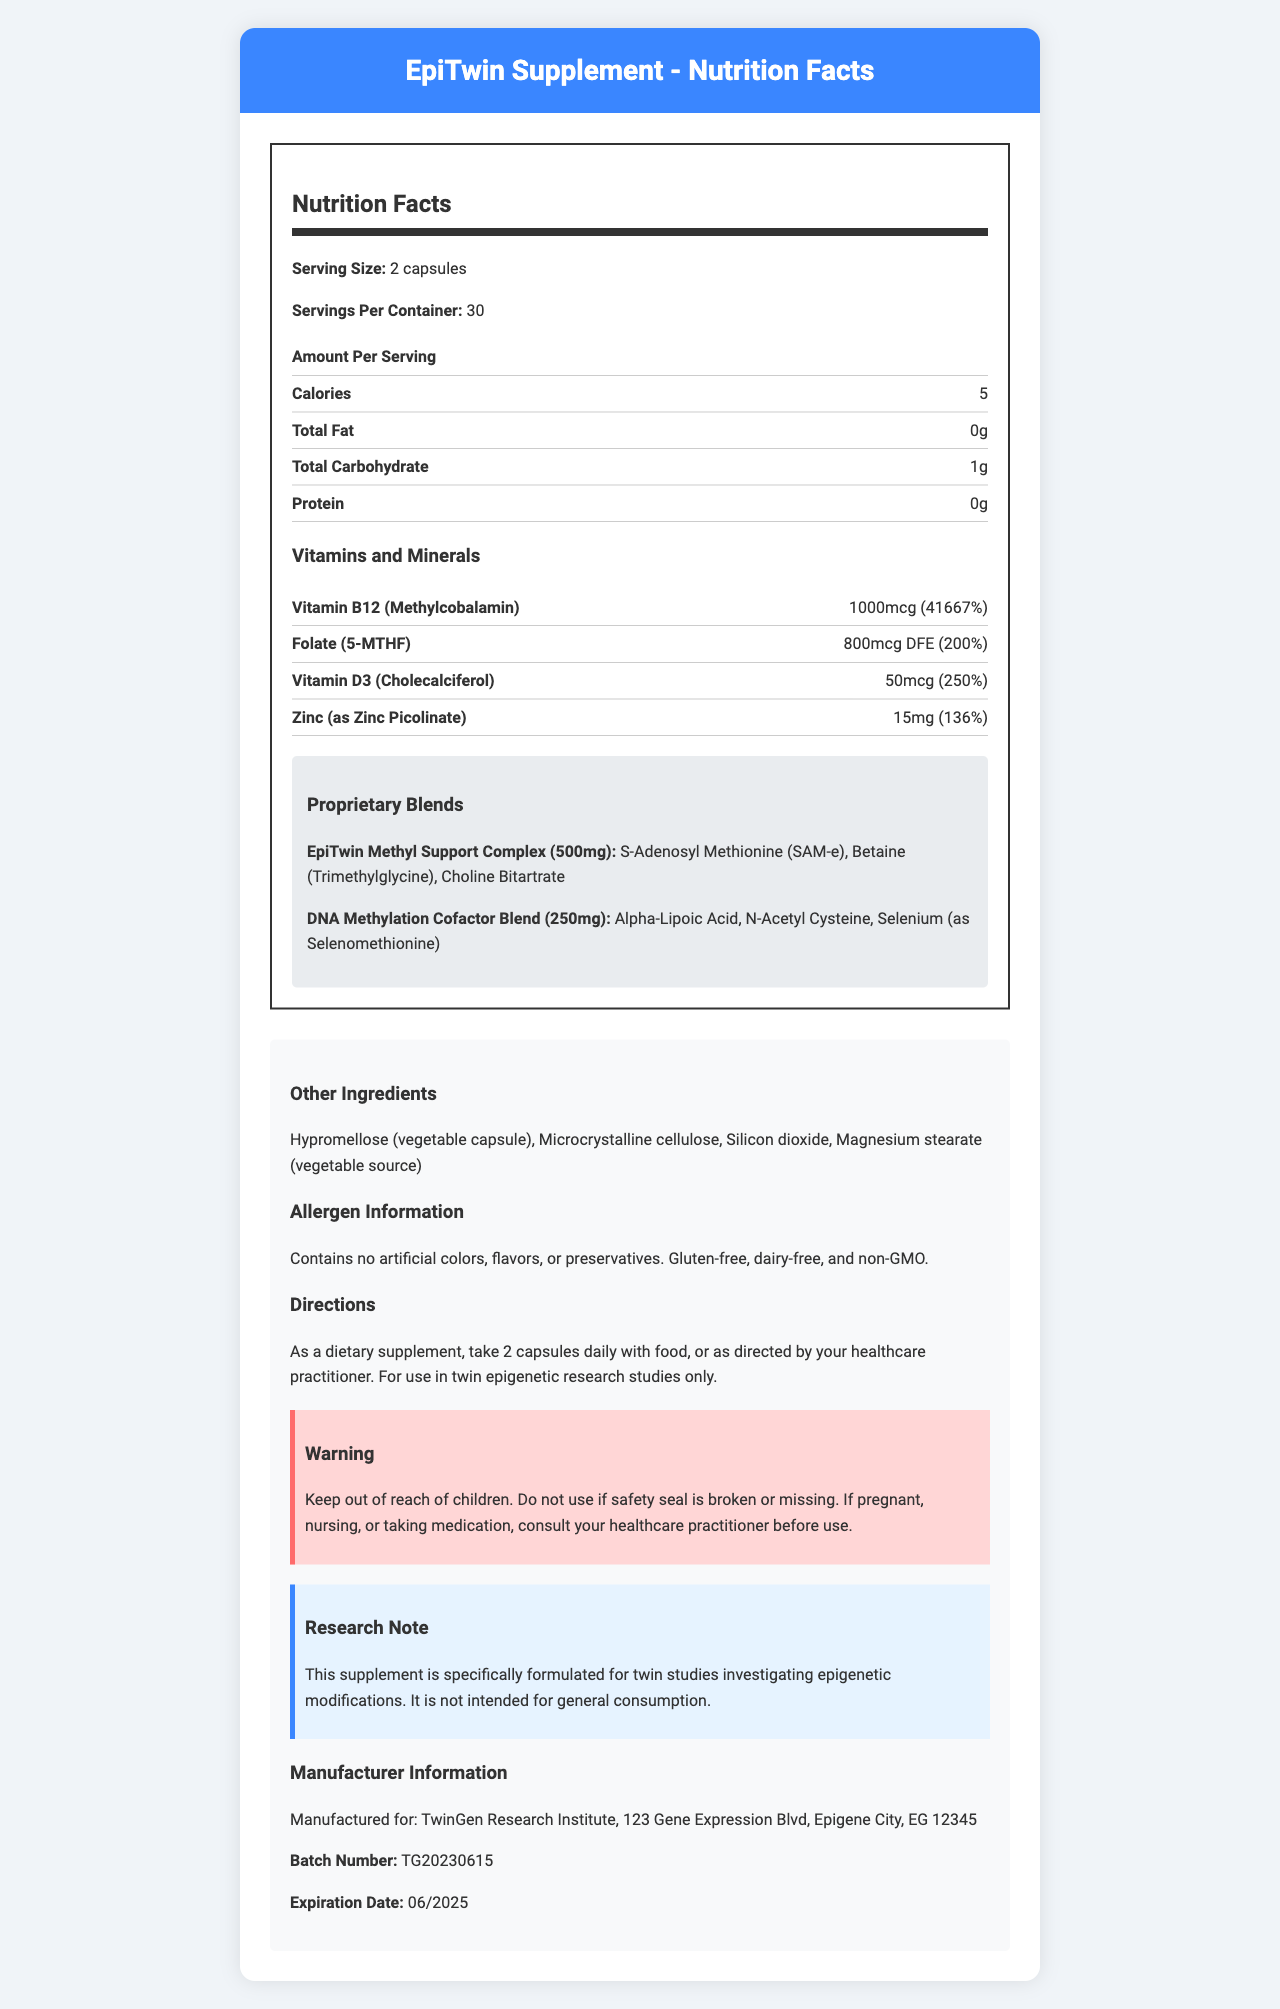what is the serving size of the EpiTwin Supplement? The serving size is clearly mentioned as "2 capsules" in the document under the Nutrition Facts section.
Answer: 2 capsules how many calories are there per serving? The document states that each serving contains 5 calories.
Answer: 5 calories which vitamin has the highest daily value percentage? The document lists the daily value percentage for Vitamin B12 as 41667%, which is the highest among the listed vitamins and minerals.
Answer: Vitamin B12 (Methylcobalamin) how much of the EpiTwin Methyl Support Complex is in each serving? The document specifies the amount of the EpiTwin Methyl Support Complex as 500mg per serving in the Proprietary Blends section.
Answer: 500mg what are the directions for using this supplement? The Directions section in the document instructs to take 2 capsules daily with food, or as directed by a healthcare practitioner.
Answer: Take 2 capsules daily with food, or as directed by your healthcare practitioner. does the supplement contain any artificial colors, flavors, or preservatives? The allergen information states that it contains no artificial colors, flavors, or preservatives.
Answer: No what is the expiration date of the product? The document lists the expiration date as 06/2025 in the Manufacturer Information section.
Answer: 06/2025 pick the correct statement: A. The supplement contains Gluten. B. The supplement is GMO. C. The supplement is gluten-free. The allergen information clearly states that the supplement is gluten-free.
Answer: C which of the following is an ingredient in the DNA Methylation Cofactor Blend? I. Selenomethionine II. S-Adenosyl Methionine III. Choline Bitartrate Selenomethionine is listed as an ingredient in the DNA Methylation Cofactor Blend, while the other ingredients belong to different blends.
Answer: I is the supplement intended for general consumption? The research note explicitly states that the supplement is specifically formulated for twin studies and is not intended for general consumption.
Answer: No what is the main idea of this document? The document serves to inform about the EpiTwin Supplement's nutritional and ingredient specifics, its use case in research, and other relevant details to ensure proper usage and safety.
Answer: The document provides detailed nutrition facts and product information about the EpiTwin Supplement, a specialized supplement formulated for twin epigenetic research studies. It includes serving sizes, nutritional content, proprietary blends, other ingredients, allergen information, directions for use, warnings, research notes, and manufacturer details. what is the effect of the supplement on an individual's epigenetic markers? The document does not provide any specific information on the effects of the supplement on an individual's epigenetic markers.
Answer: Not enough information 